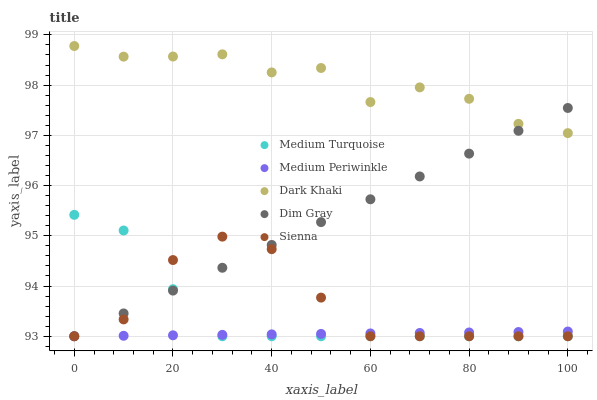Does Medium Periwinkle have the minimum area under the curve?
Answer yes or no. Yes. Does Dark Khaki have the maximum area under the curve?
Answer yes or no. Yes. Does Sienna have the minimum area under the curve?
Answer yes or no. No. Does Sienna have the maximum area under the curve?
Answer yes or no. No. Is Medium Periwinkle the smoothest?
Answer yes or no. Yes. Is Sienna the roughest?
Answer yes or no. Yes. Is Dim Gray the smoothest?
Answer yes or no. No. Is Dim Gray the roughest?
Answer yes or no. No. Does Sienna have the lowest value?
Answer yes or no. Yes. Does Dark Khaki have the highest value?
Answer yes or no. Yes. Does Sienna have the highest value?
Answer yes or no. No. Is Medium Turquoise less than Dark Khaki?
Answer yes or no. Yes. Is Dark Khaki greater than Medium Turquoise?
Answer yes or no. Yes. Does Sienna intersect Medium Periwinkle?
Answer yes or no. Yes. Is Sienna less than Medium Periwinkle?
Answer yes or no. No. Is Sienna greater than Medium Periwinkle?
Answer yes or no. No. Does Medium Turquoise intersect Dark Khaki?
Answer yes or no. No. 